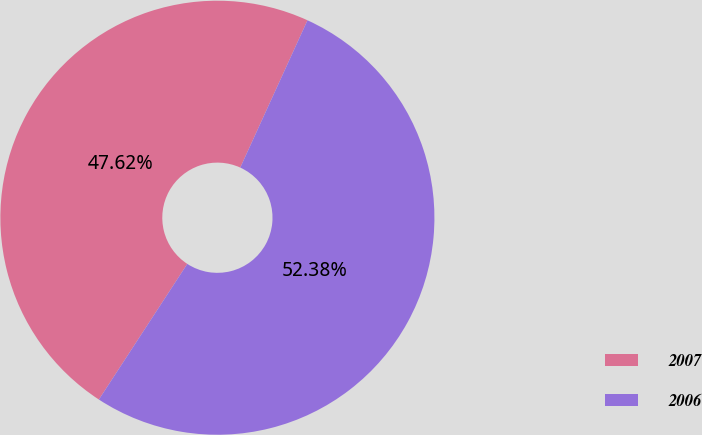Convert chart to OTSL. <chart><loc_0><loc_0><loc_500><loc_500><pie_chart><fcel>2007<fcel>2006<nl><fcel>47.62%<fcel>52.38%<nl></chart> 